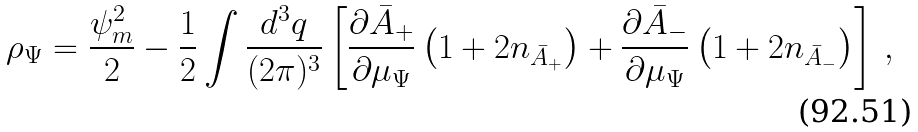Convert formula to latex. <formula><loc_0><loc_0><loc_500><loc_500>\rho _ { \Psi } = \frac { \psi _ { m } ^ { 2 } } { 2 } - \frac { 1 } { 2 } \int \frac { d ^ { 3 } { q } } { ( 2 \pi ) ^ { 3 } } \left [ \frac { \partial \bar { A } _ { + } } { \partial \mu _ { \Psi } } \left ( 1 + 2 n _ { \bar { A } _ { + } } \right ) + \frac { \partial \bar { A } _ { - } } { \partial \mu _ { \Psi } } \left ( 1 + 2 n _ { \bar { A } _ { - } } \right ) \right ] \, ,</formula> 